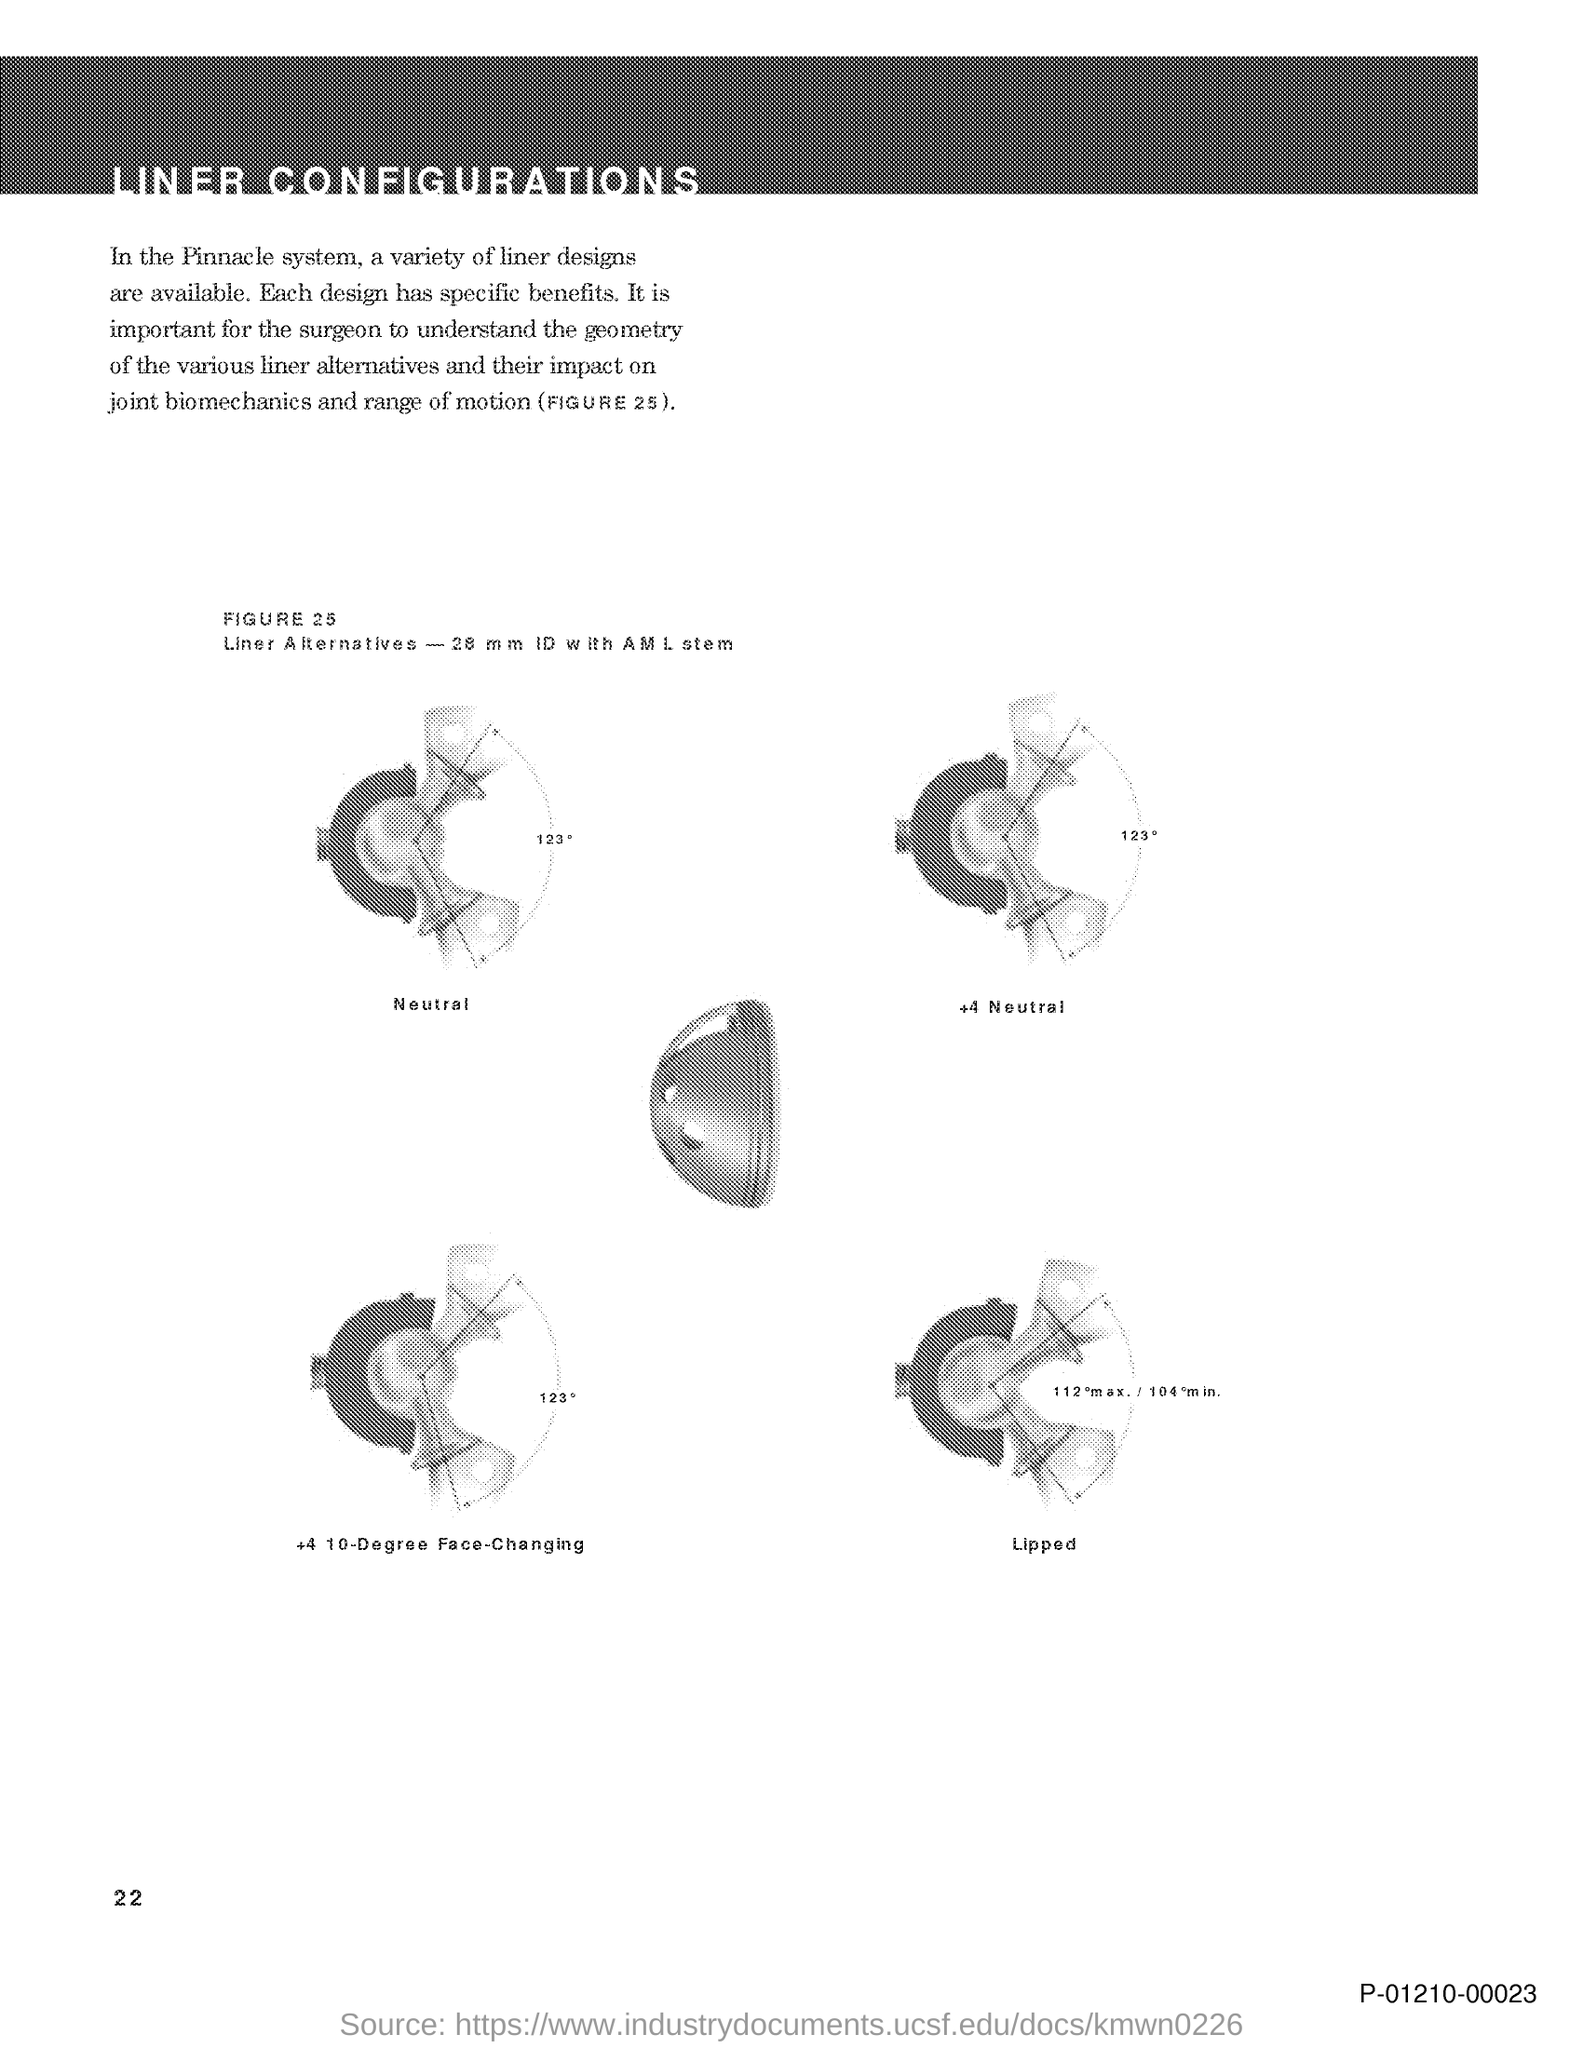List a handful of essential elements in this visual. The text "What is the code at the bottom right corner of the page? P-01210-00023.." is a question asking for information about a code located in the bottom right corner of a page. The speaker is asking for the page number of a document, and provides the page number 22. The document title is 'LINER CONFIGURATIONS.' 